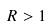Convert formula to latex. <formula><loc_0><loc_0><loc_500><loc_500>R > 1</formula> 